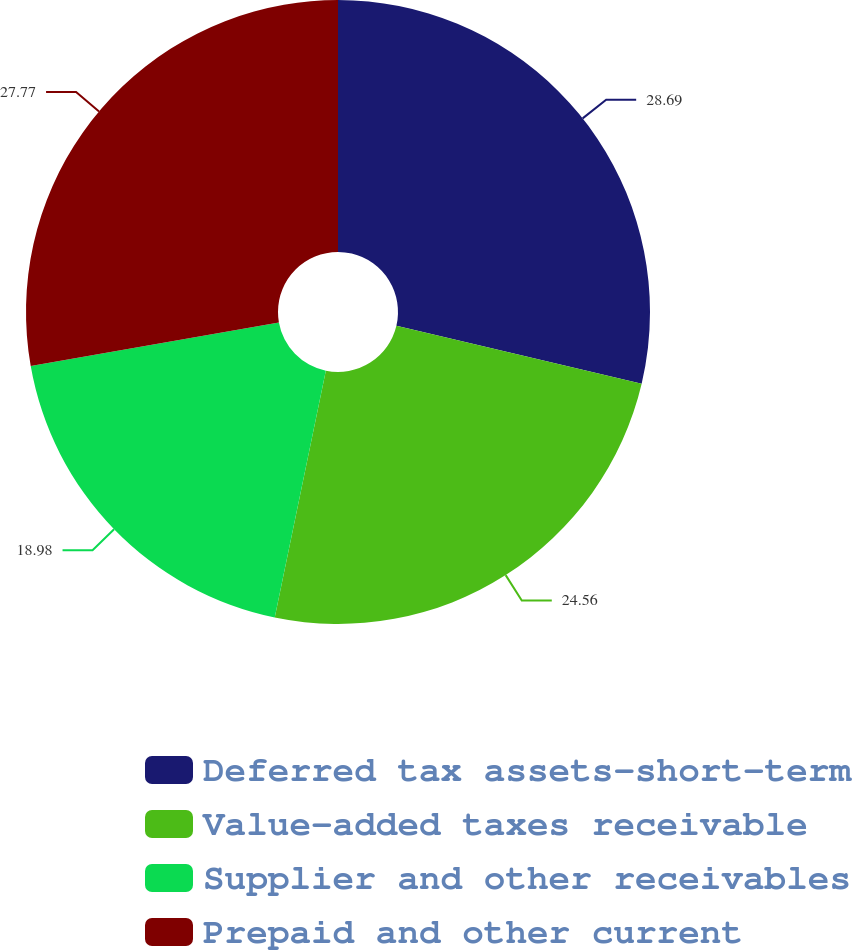Convert chart to OTSL. <chart><loc_0><loc_0><loc_500><loc_500><pie_chart><fcel>Deferred tax assets-short-term<fcel>Value-added taxes receivable<fcel>Supplier and other receivables<fcel>Prepaid and other current<nl><fcel>28.69%<fcel>24.56%<fcel>18.98%<fcel>27.77%<nl></chart> 